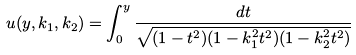Convert formula to latex. <formula><loc_0><loc_0><loc_500><loc_500>u ( y , k _ { 1 } , k _ { 2 } ) = \int _ { 0 } ^ { y } \frac { d t } { \sqrt { ( 1 - t ^ { 2 } ) ( 1 - k _ { 1 } ^ { 2 } t ^ { 2 } ) ( 1 - k _ { 2 } ^ { 2 } t ^ { 2 } ) } }</formula> 